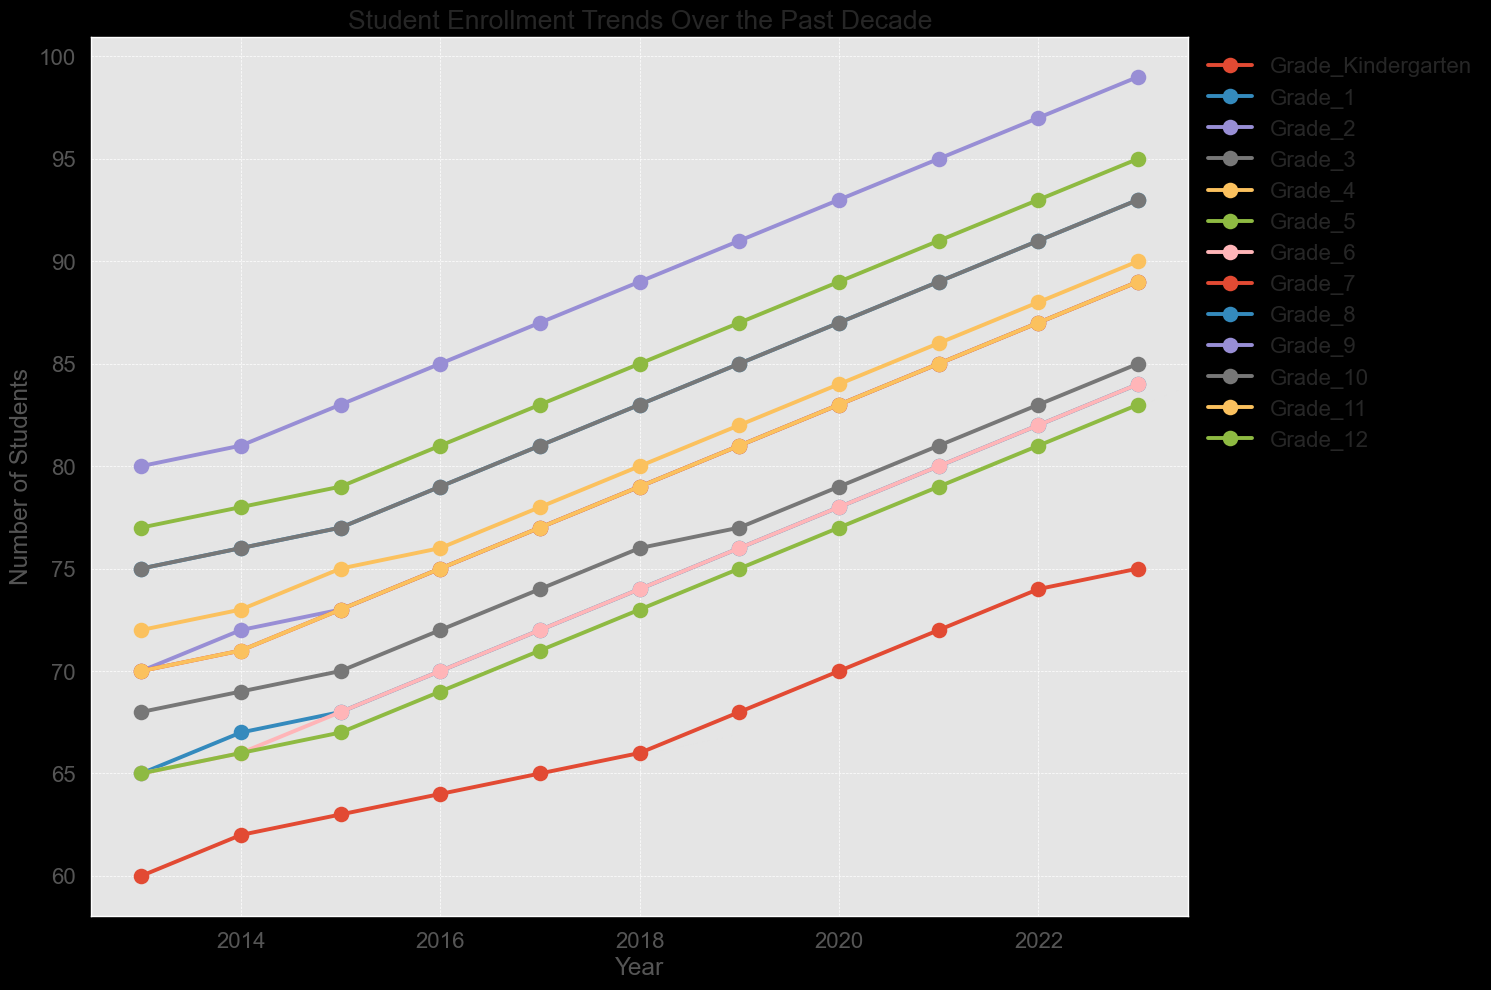what trend is observed overall across all grade levels from 2013 to 2023? The overall trend across all grade levels shows an increase in student enrollment. Each line representing a grade level generally slopes upward, indicating a rise in the number of students over the decade.
Answer: Increasing trend Which grade level experienced the highest increase in student enrollment from 2013 to 2023? To find the highest increase, subtract the 2013 enrollment from the 2023 enrollment for each grade and compare the results. Grade_9 had the highest growth, increasing from 80 to 99, a difference of 19 students.
Answer: Grade_9 What is the total number of students enrolled across all grades in 2023? Sum the enrollments for each grade in 2023: 75 (Kindergarten) + 84 (Grade_1) + 89 (Grade_2) + 85 (Grade_3) + 90 (Grade_4) + 95 (Grade_5) + 84 (Grade_6) + 89 (Grade_7) + 93 (Grade_8) + 99 (Grade_9) + 93 (Grade_10) + 89 (Grade_11) + 83 (Grade_12) = 1048.
Answer: 1048 Which two grades have the closest enrollment numbers in 2020? Compare the enrollment numbers across all grades in 2020 and check for the smallest difference. In 2020, Grade_10 and Grade_8 both have 87 students, so the closest difference is 0 students.
Answer: Grade_10 and Grade_8 By how much did the enrollment in Grade_12 increase from 2013 to 2023? Calculate the difference between the enrollment numbers for Grade_12 in 2013 and 2023: 83 - 65 = 18.
Answer: 18 How does the enrollment trend for Grade_3 compare to Grade_4 from 2013 to 2023? Observe the lines for both grades; while both have an increasing trend, Grade_4 shows a slightly steeper increase from 72 to 90 compared to Grade_3's increase from 68 to 85. Grade_4's slope is greater, indicating a sharper rise.
Answer: Grade_4 has a steeper increase Which grade had the lowest enrollment in 2015 and what was its value? Find the enrollment values in 2015 and identify the lowest: Kindergarten had the lowest enrollment of 63 students.
Answer: Kindergarten with 63 What is the average enrollment for Grade_7 from 2013 to 2023? Sum the enrollments for Grade_7 from 2013 to 2023 and divide by the number of years: (70 + 71 + 73 + 75 + 77 + 79 + 81 + 83 + 85 + 87 + 89) / 11 = 78.
Answer: 78 